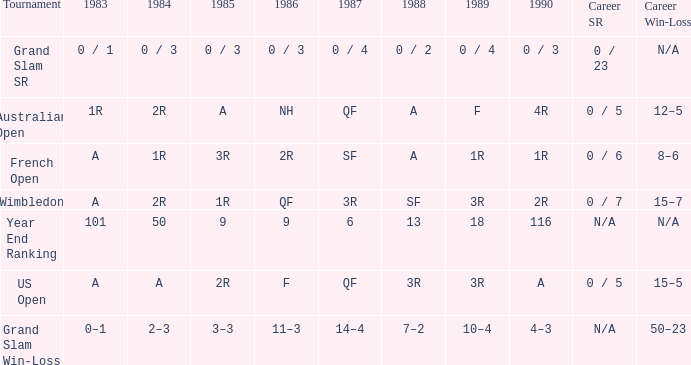What tournament has 0 / 5 as career SR and A as 1983? US Open. 